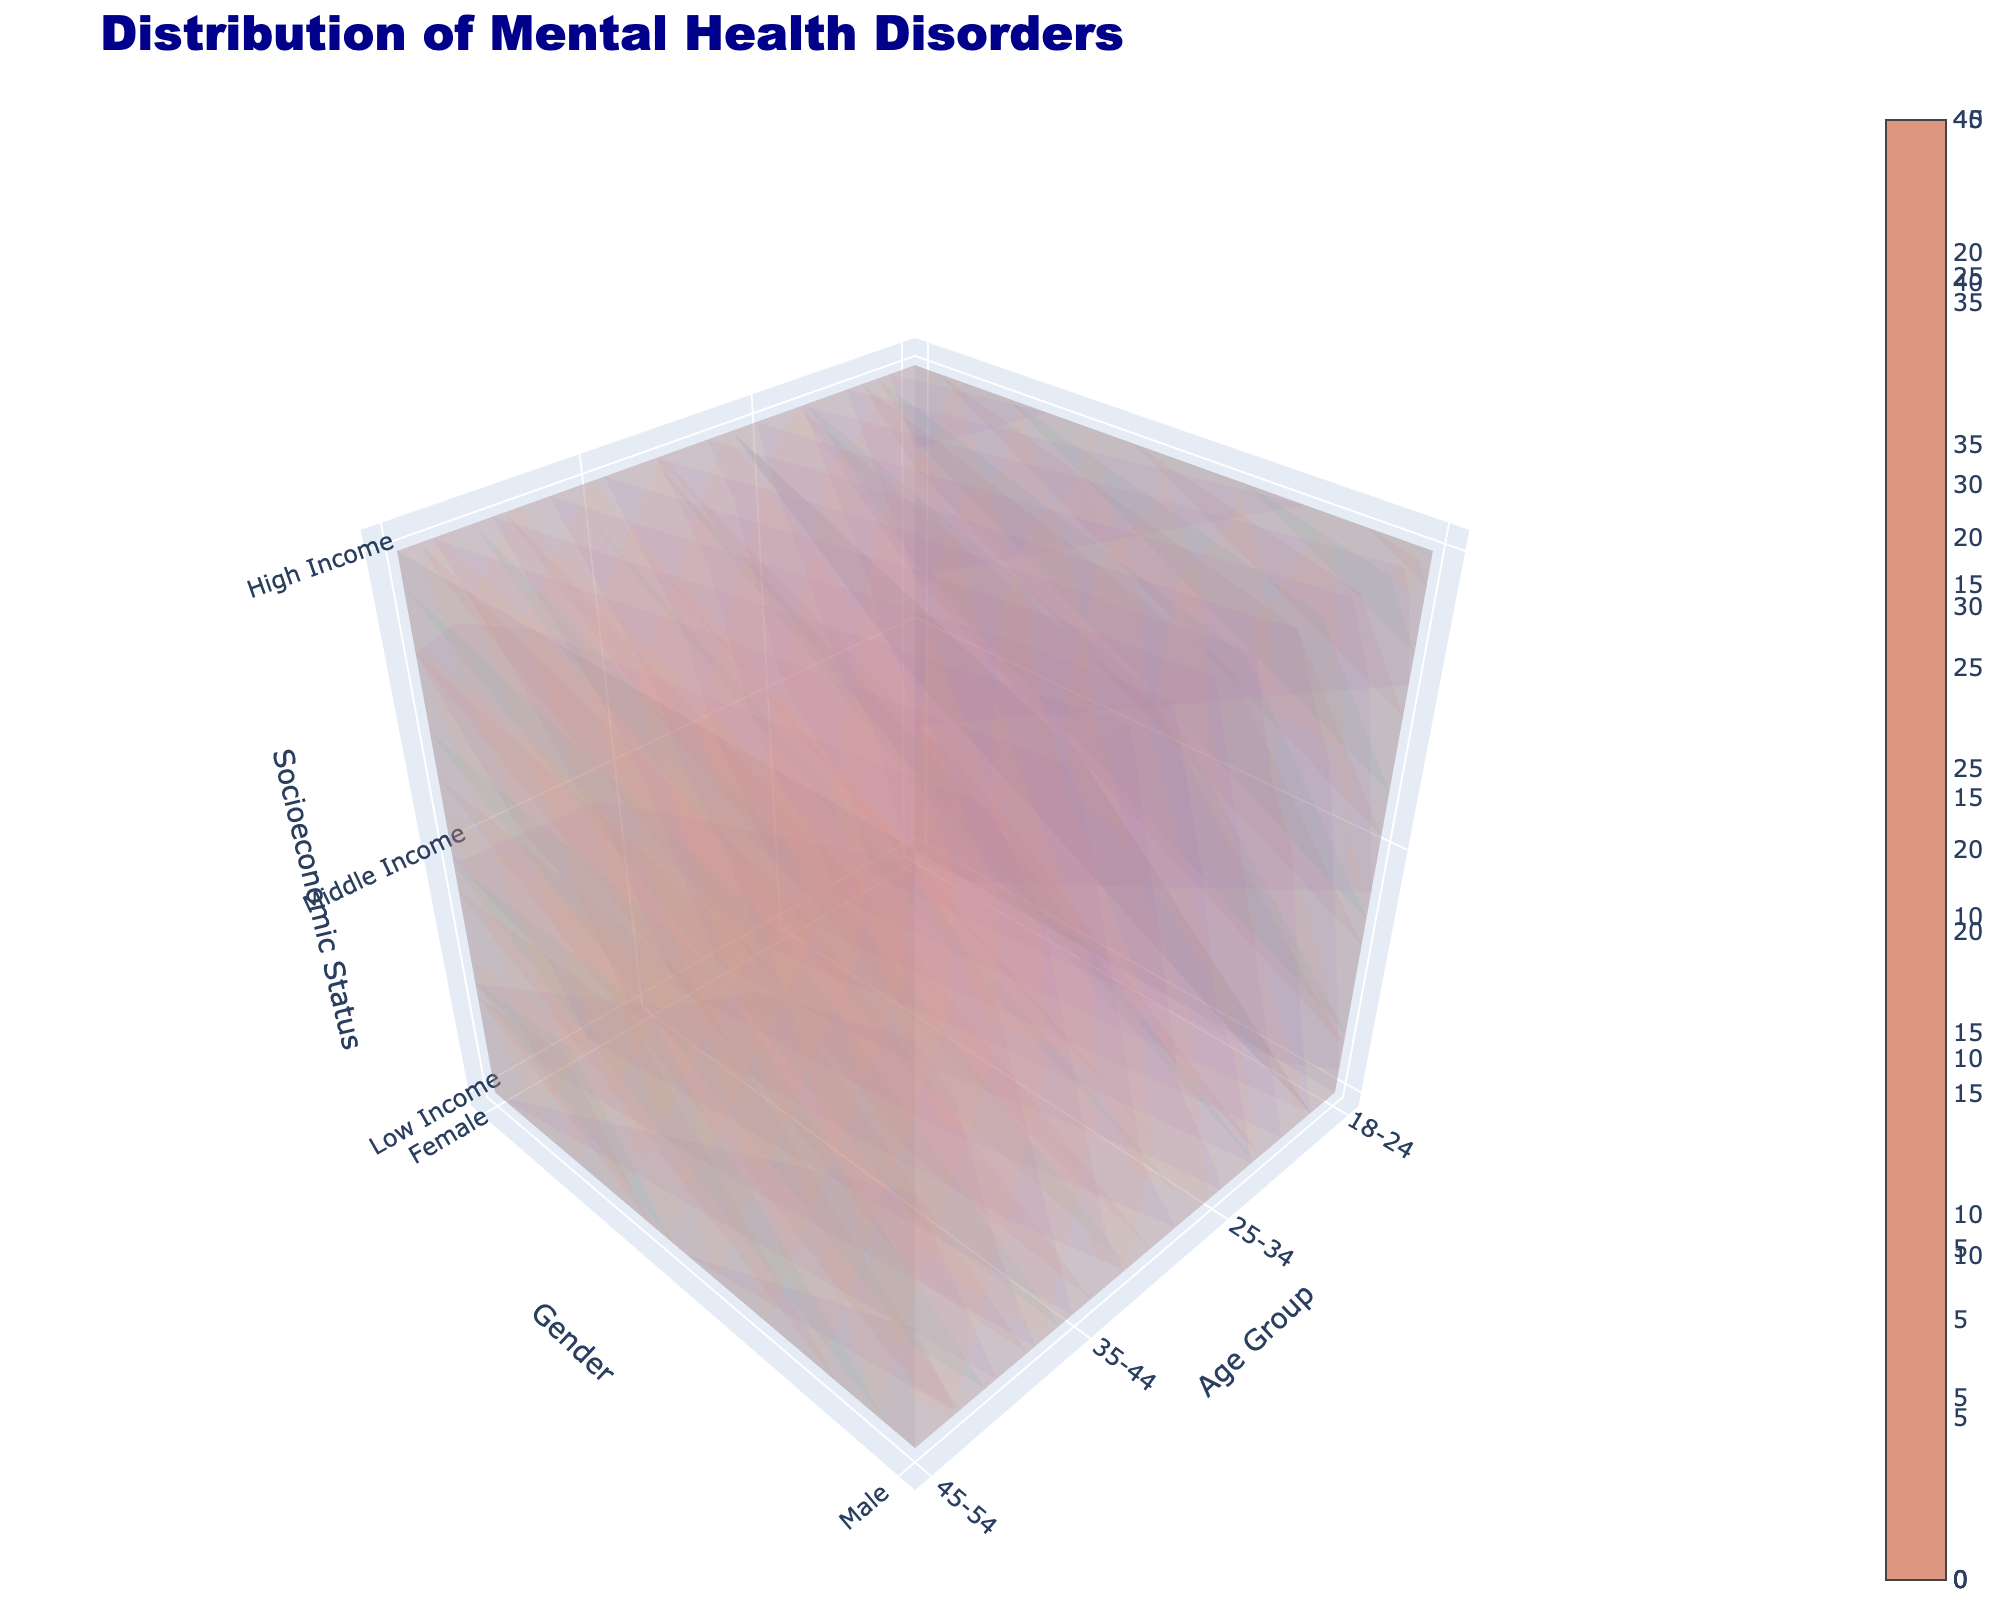What is the title of the figure? The title of the figure appears prominently above the plot. It gives a quick summary of what the figure represents.
Answer: Distribution of Mental Health Disorders What are the three axes labeled in the plot? The labels for the axes can be seen along the sides of the 3D plot, each indicating a specific dimension of the data.
Answer: Age Group, Gender, Socioeconomic Status Which mental health disorder has the highest value in the '18-24, Female, Low Income' group? To find this, locate the section representing '18-24' for age, 'Female' for gender, and 'Low Income' for socioeconomic status and compare the values for each disorder.
Answer: Anxiety In the '25-34, Male, High Income' group, what is the value for Eating Disorders? This requires identifying the '25-34' age group, 'Male' gender, and 'High Income' socioeconomic status section and reading the Eating Disorders value.
Answer: 3 Which age group shows the highest average value for Depression across all genders and socioeconomic statuses? To determine this, calculate the average Depression values for each age group by summing the values across genders and socioeconomic statuses and then dividing by the number of entries.
Answer: 45-54 Compare the median values of Anxiety between 'Low Income' and 'High Income' groups across all ages and genders. Which is higher? To find this, gather all Anxiety values for 'Low Income' and 'High Income' groups, find the median of each set, and compare them.
Answer: Low Income How does the PTSD value for '35-44, Male, Middle Income' compare to '45-54, Female, Middle Income'? Identify the PTSD values for both groups and compare them directly.
Answer: Lower Which mental health disorder shows the most significant difference between 'Low Income' and 'High Income' groups for '18-24, Female'? Calculate the difference for each disorder between 'Low Income' and 'High Income' for '18-24, Female' and identify which is largest.
Answer: Anxiety In the '35-44 age' group, which gender and socioeconomic status combination has the highest value for Eating Disorders? Look at the '35-44' age group and compare the Eating Disorder values for each gender and socioeconomic status to find the highest.
Answer: Female, Low Income 